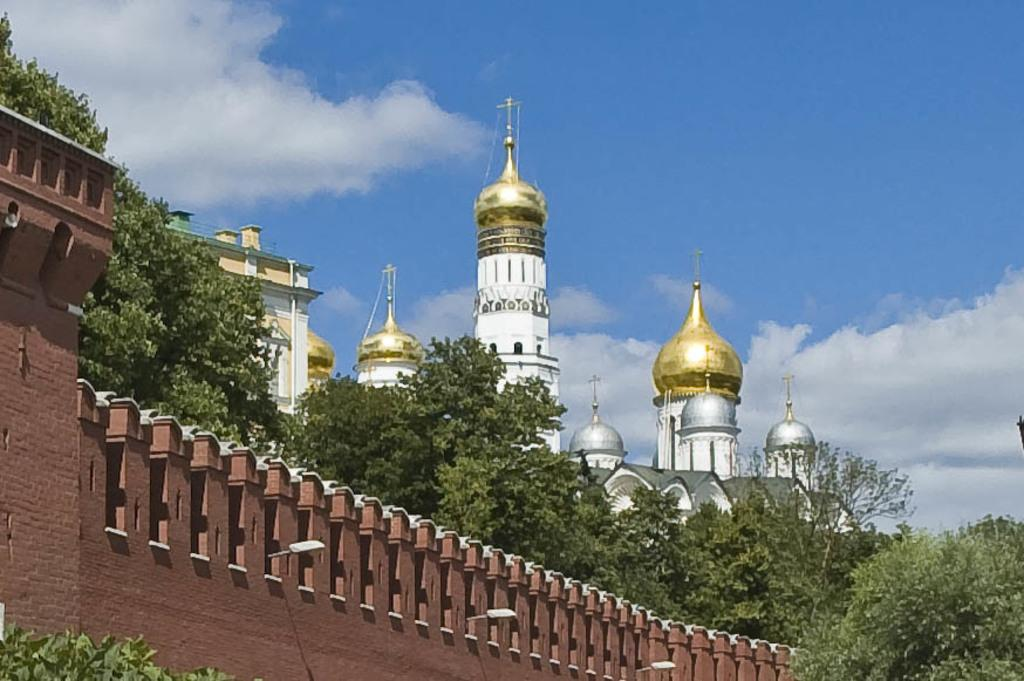What type of structure is the main subject of the image? There is a castle in the image. What other structures can be seen in the image? There is a building in the image. What type of natural elements are present in the image? There are trees in the image. What is on the left side of the image? There is a wall on the left side of the image. What is visible at the top of the image? The sky is visible at the top of the image. What type of rhythm can be heard coming from the castle in the image? There is no sound or rhythm present in the image, as it is a still photograph of a castle, building, trees, and wall. 